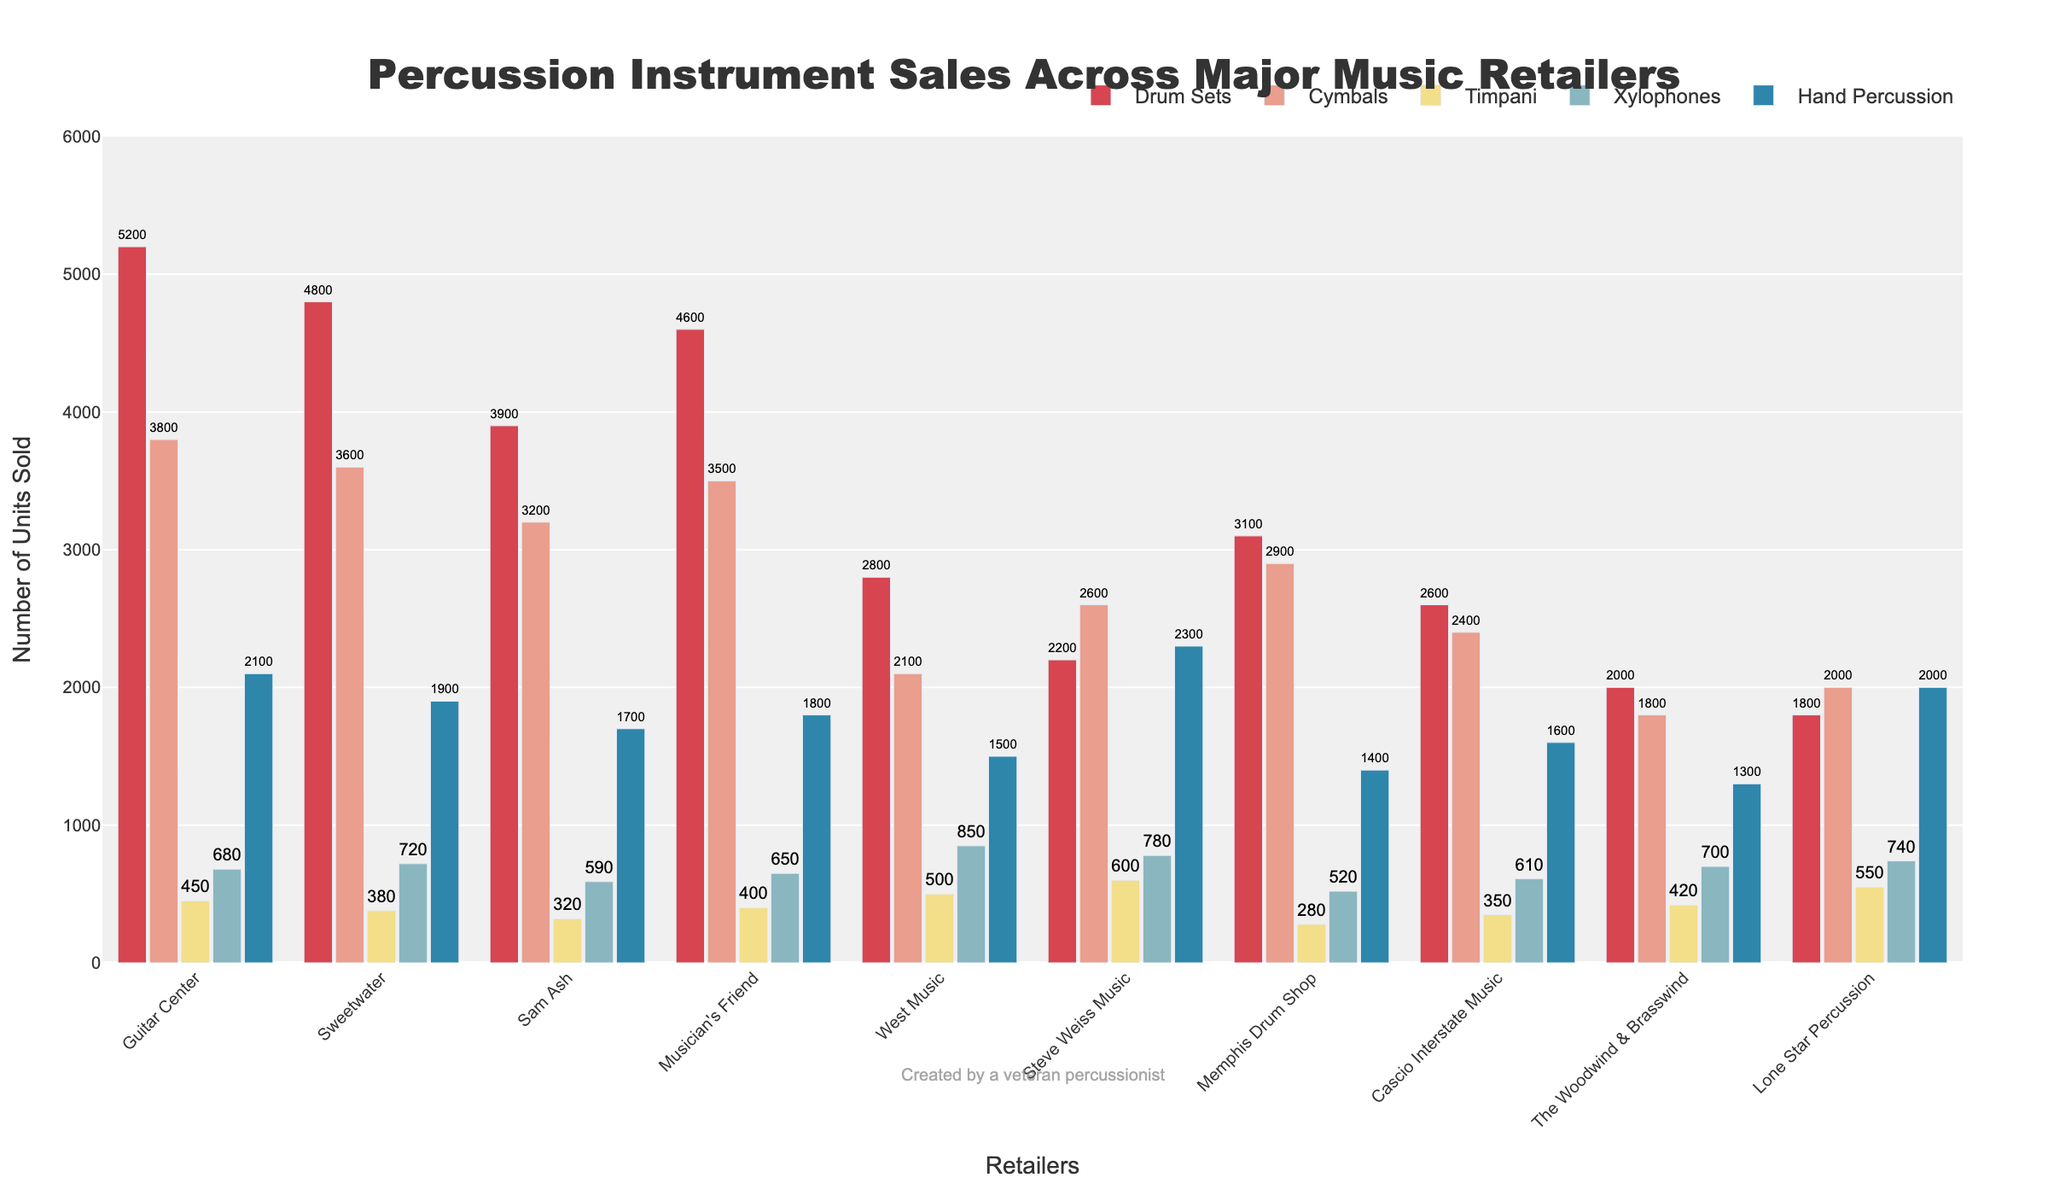Which retailer sold the most Drum Sets? Look at the bar heights for Drum Sets across all retailers. Guitar Center has the highest bar for Drum Sets.
Answer: Guitar Center Which retailer sold more Xylophones, West Music or Cascio Interstate Music? Compare the bars for Xylophones of both retailers. West Music's bar is higher than that of Cascio Interstate Music.
Answer: West Music What is the total number of Timpani sold by all retailers? Add the number of Timpani sold by each retailer: 450 + 380 + 320 + 400 + 500 + 600 + 280 + 350 + 420 + 550.
Answer: 4250 Between Guitar Center and Sweetwater, which retailer sold a higher total number of Hand Percussions and by how much? Determine the difference in the number of Hand Percussions sold: Guitar Center sold 2100, and Sweetwater sold 1900. The difference is 200.
Answer: Guitar Center, by 200 Which retailer sold the least amount of Cymbals? Look for the lowest bar among all retailers for Cymbals. The Woodwind & Brasswind has the lowest bar for Cymbals.
Answer: The Woodwind & Brasswind What is the average number of Drum Sets sold by all retailers? Sum the Drum Sets sold by each retailer and divide by the number of retailers: (5200 + 4800 + 3900 + 4600 + 2800 + 2200 + 3100 + 2600 + 2000 + 1800) / 10.
Answer: 3300 Which instrument has the highest total sales across all retailers? Sum the sales of all instruments across all retailers and compare: Drum Sets (32000), Cymbals (28900), Timpani (4250), Xylophones (6840), Hand Percussion (18100).
Answer: Drum Sets Which three retailers have sold more than 700 Xylophones? Identify retailers with bars greater than 700 for Xylophones: West Music, Steve Weiss Music, and Lone Star Percussion.
Answer: West Music, Steve Weiss Music, Lone Star Percussion What is the difference in total Hand Percussion sales between the retailer with the highest and the one with the lowest sales? Determine the highest and lowest Hand Percussion sales: Steve Weiss Music (2300) and The Woodwind & Brasswind (1300). The difference is 1000.
Answer: 1000 